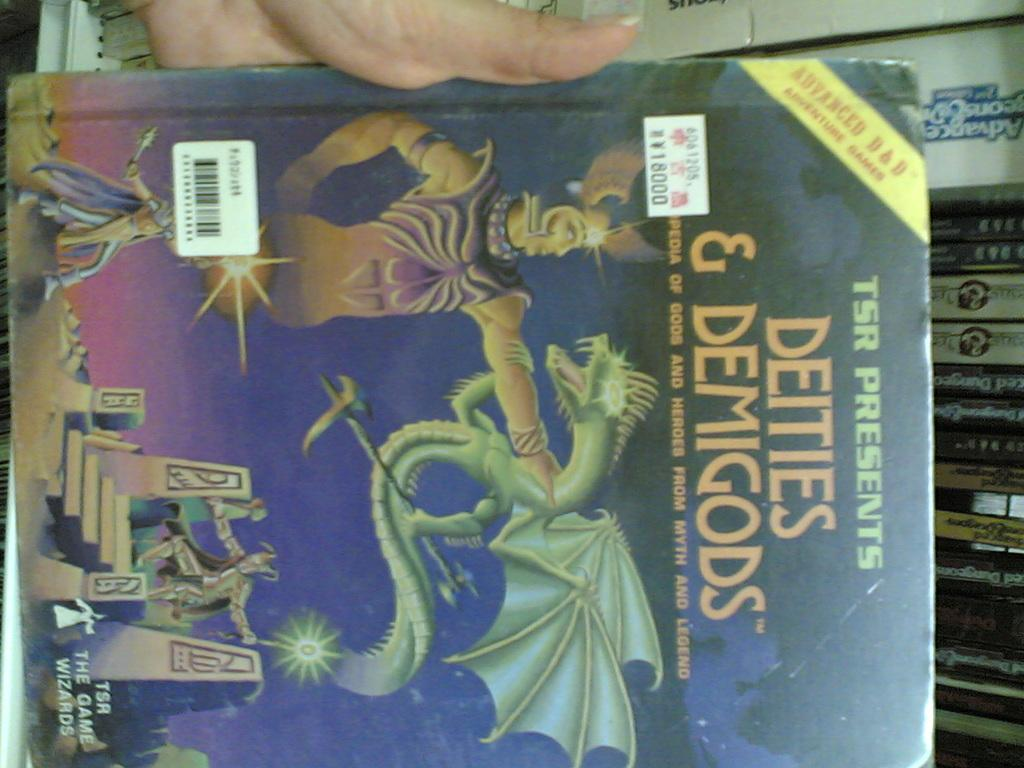<image>
Describe the image concisely. A large book titled "Deities and Demigods" being held by a woman. 